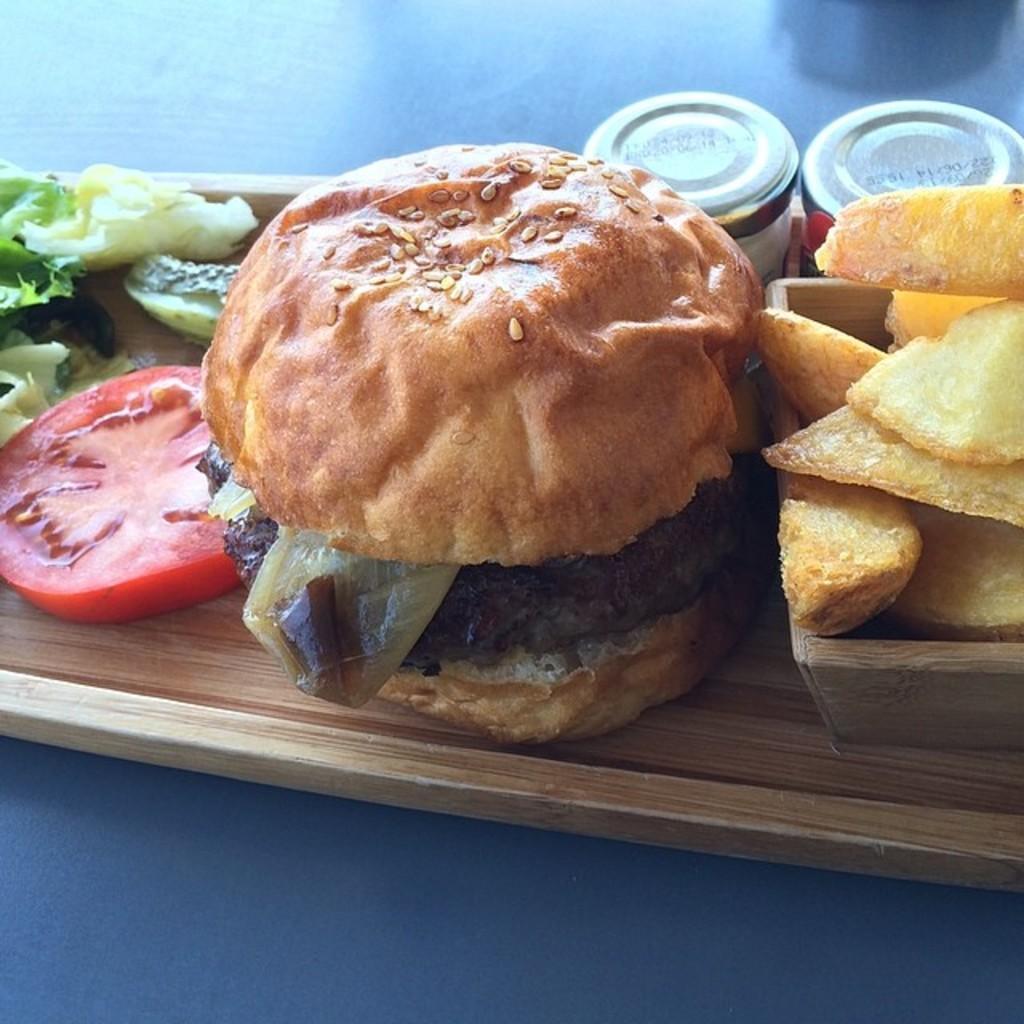Please provide a concise description of this image. Bottom of the image there is a table, on the table there are some food items and bottles. 